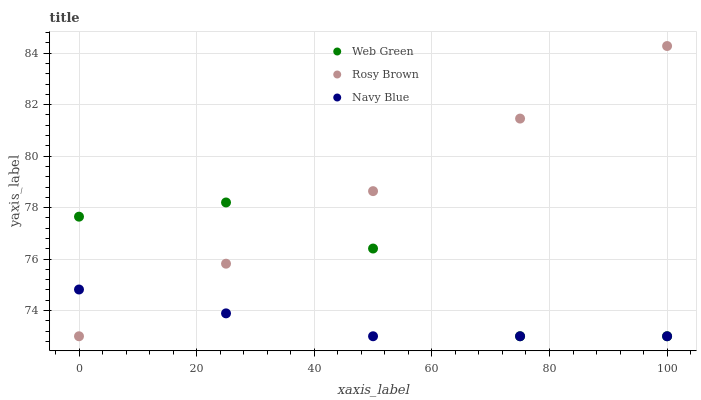Does Navy Blue have the minimum area under the curve?
Answer yes or no. Yes. Does Rosy Brown have the maximum area under the curve?
Answer yes or no. Yes. Does Web Green have the minimum area under the curve?
Answer yes or no. No. Does Web Green have the maximum area under the curve?
Answer yes or no. No. Is Rosy Brown the smoothest?
Answer yes or no. Yes. Is Web Green the roughest?
Answer yes or no. Yes. Is Web Green the smoothest?
Answer yes or no. No. Is Rosy Brown the roughest?
Answer yes or no. No. Does Navy Blue have the lowest value?
Answer yes or no. Yes. Does Rosy Brown have the highest value?
Answer yes or no. Yes. Does Web Green have the highest value?
Answer yes or no. No. Does Navy Blue intersect Web Green?
Answer yes or no. Yes. Is Navy Blue less than Web Green?
Answer yes or no. No. Is Navy Blue greater than Web Green?
Answer yes or no. No. 